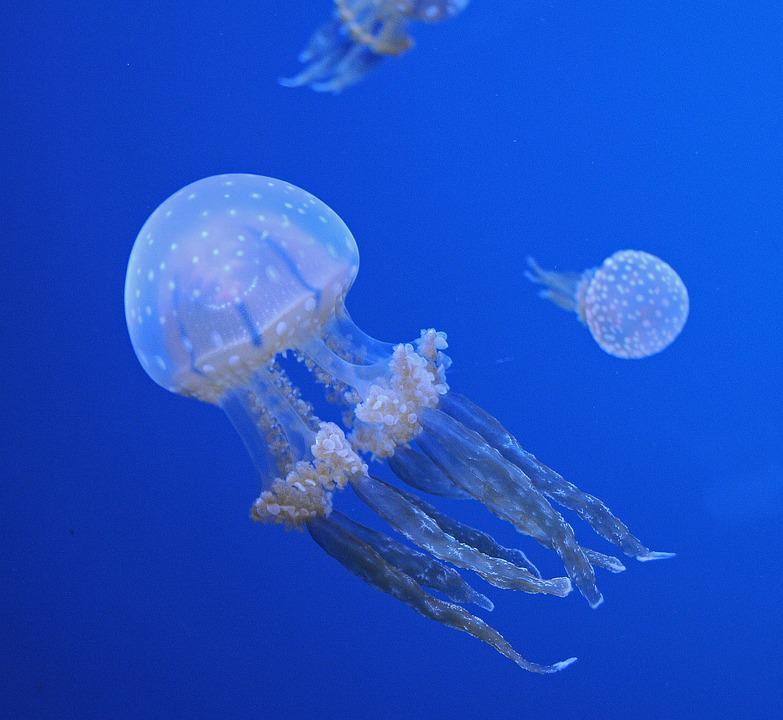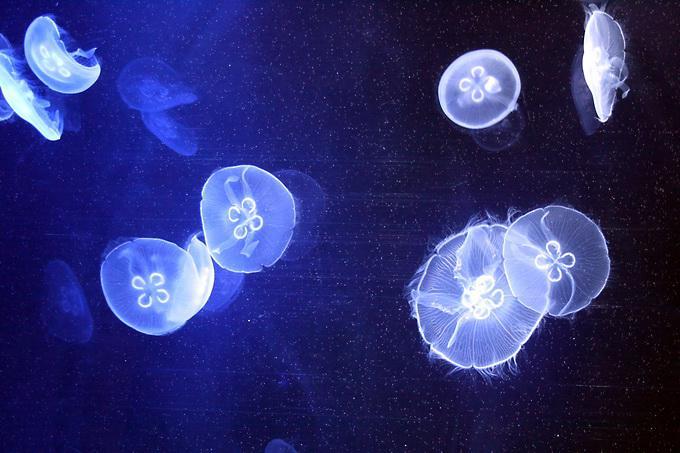The first image is the image on the left, the second image is the image on the right. Assess this claim about the two images: "there is only one jellyfish on one of the images". Correct or not? Answer yes or no. No. 